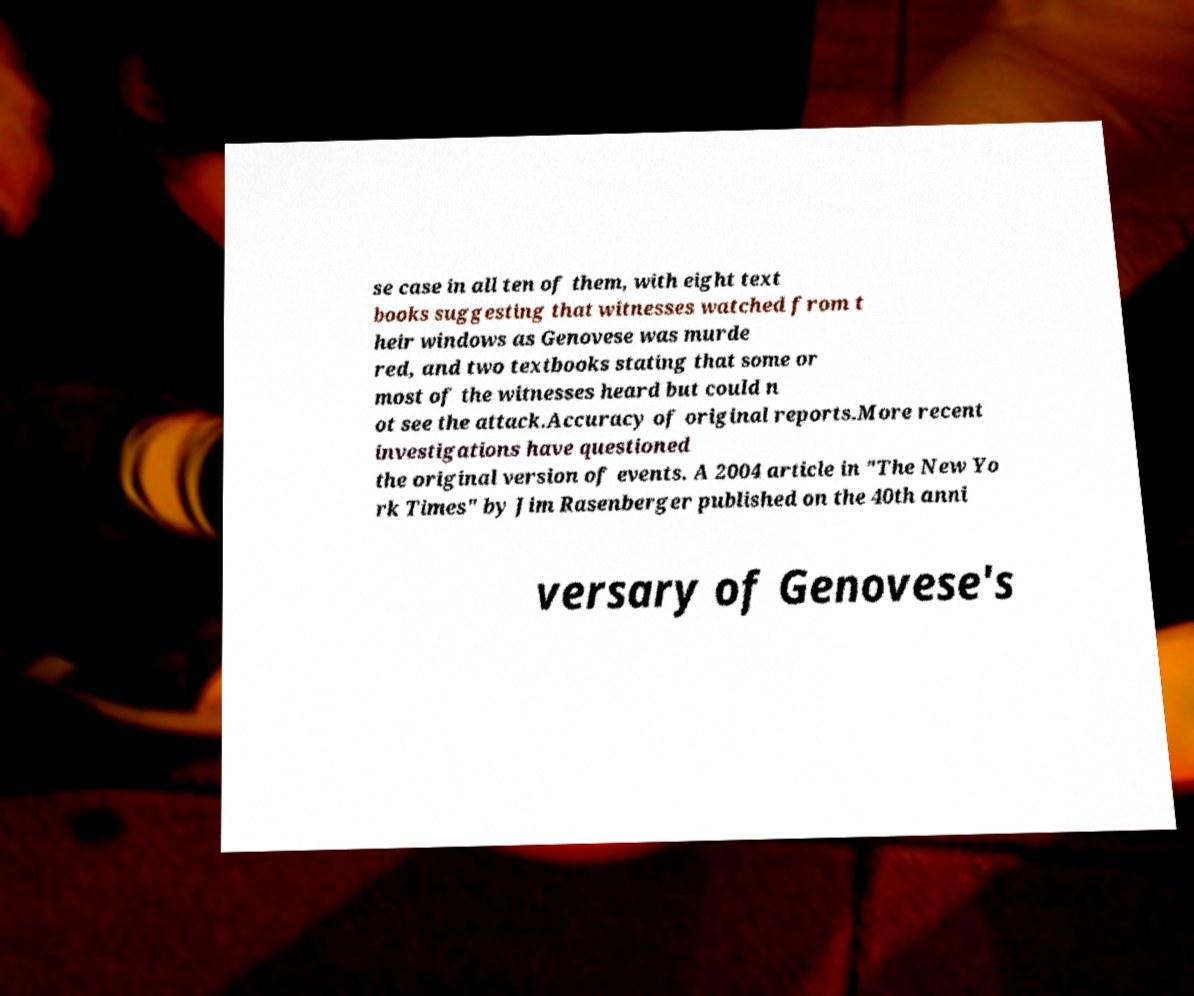Could you extract and type out the text from this image? se case in all ten of them, with eight text books suggesting that witnesses watched from t heir windows as Genovese was murde red, and two textbooks stating that some or most of the witnesses heard but could n ot see the attack.Accuracy of original reports.More recent investigations have questioned the original version of events. A 2004 article in "The New Yo rk Times" by Jim Rasenberger published on the 40th anni versary of Genovese's 